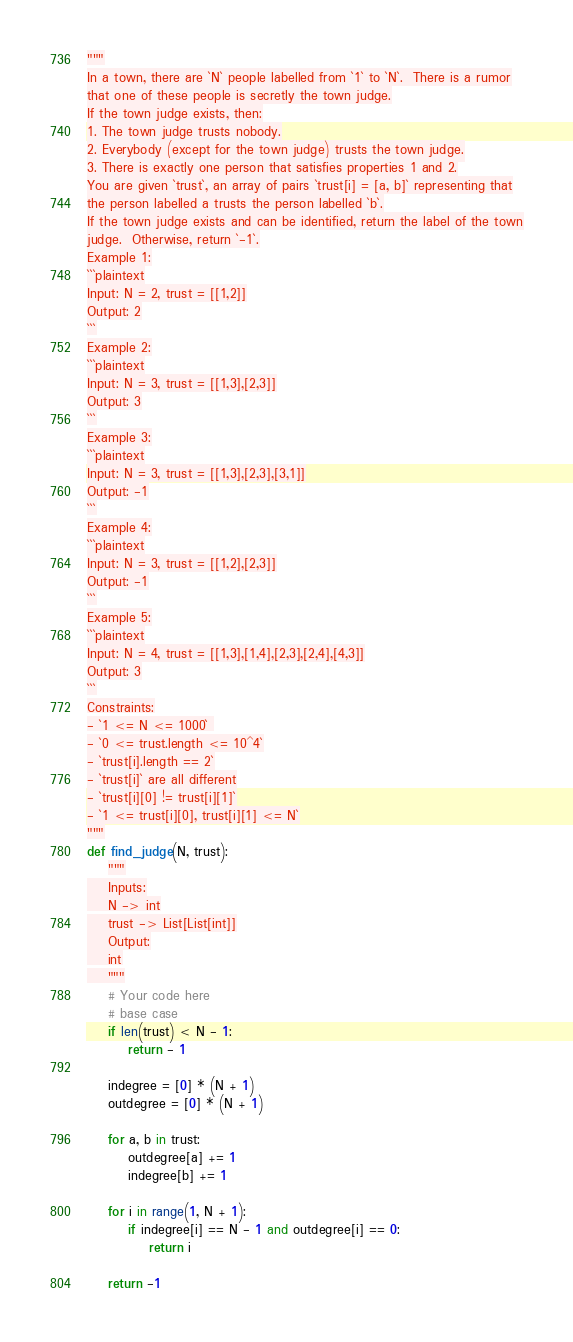Convert code to text. <code><loc_0><loc_0><loc_500><loc_500><_Python_>"""
In a town, there are `N` people labelled from `1` to `N`.  There is a rumor
that one of these people is secretly the town judge.
If the town judge exists, then:
1. The town judge trusts nobody.
2. Everybody (except for the town judge) trusts the town judge.
3. There is exactly one person that satisfies properties 1 and 2.
You are given `trust`, an array of pairs `trust[i] = [a, b]` representing that
the person labelled a trusts the person labelled `b`.
If the town judge exists and can be identified, return the label of the town
judge.  Otherwise, return `-1`.
Example 1:
```plaintext
Input: N = 2, trust = [[1,2]]
Output: 2
```
Example 2:
```plaintext
Input: N = 3, trust = [[1,3],[2,3]]
Output: 3
```
Example 3:
```plaintext
Input: N = 3, trust = [[1,3],[2,3],[3,1]]
Output: -1
```
Example 4:
```plaintext
Input: N = 3, trust = [[1,2],[2,3]]
Output: -1
```
Example 5:
```plaintext
Input: N = 4, trust = [[1,3],[1,4],[2,3],[2,4],[4,3]]
Output: 3
```
Constraints:
- `1 <= N <= 1000` 
- `0 <= trust.length <= 10^4`
- `trust[i].length == 2`
- `trust[i]` are all different
- `trust[i][0] != trust[i][1]`
- `1 <= trust[i][0], trust[i][1] <= N`
"""
def find_judge(N, trust):
    """
    Inputs:
    N -> int
    trust -> List[List[int]]
    Output:
    int
    """
    # Your code here
    # base case
    if len(trust) < N - 1:
        return - 1
    
    indegree = [0] * (N + 1)
    outdegree = [0] * (N + 1)

    for a, b in trust:
        outdegree[a] += 1
        indegree[b] += 1

    for i in range(1, N + 1):
        if indegree[i] == N - 1 and outdegree[i] == 0:
            return i
    
    return -1
</code> 